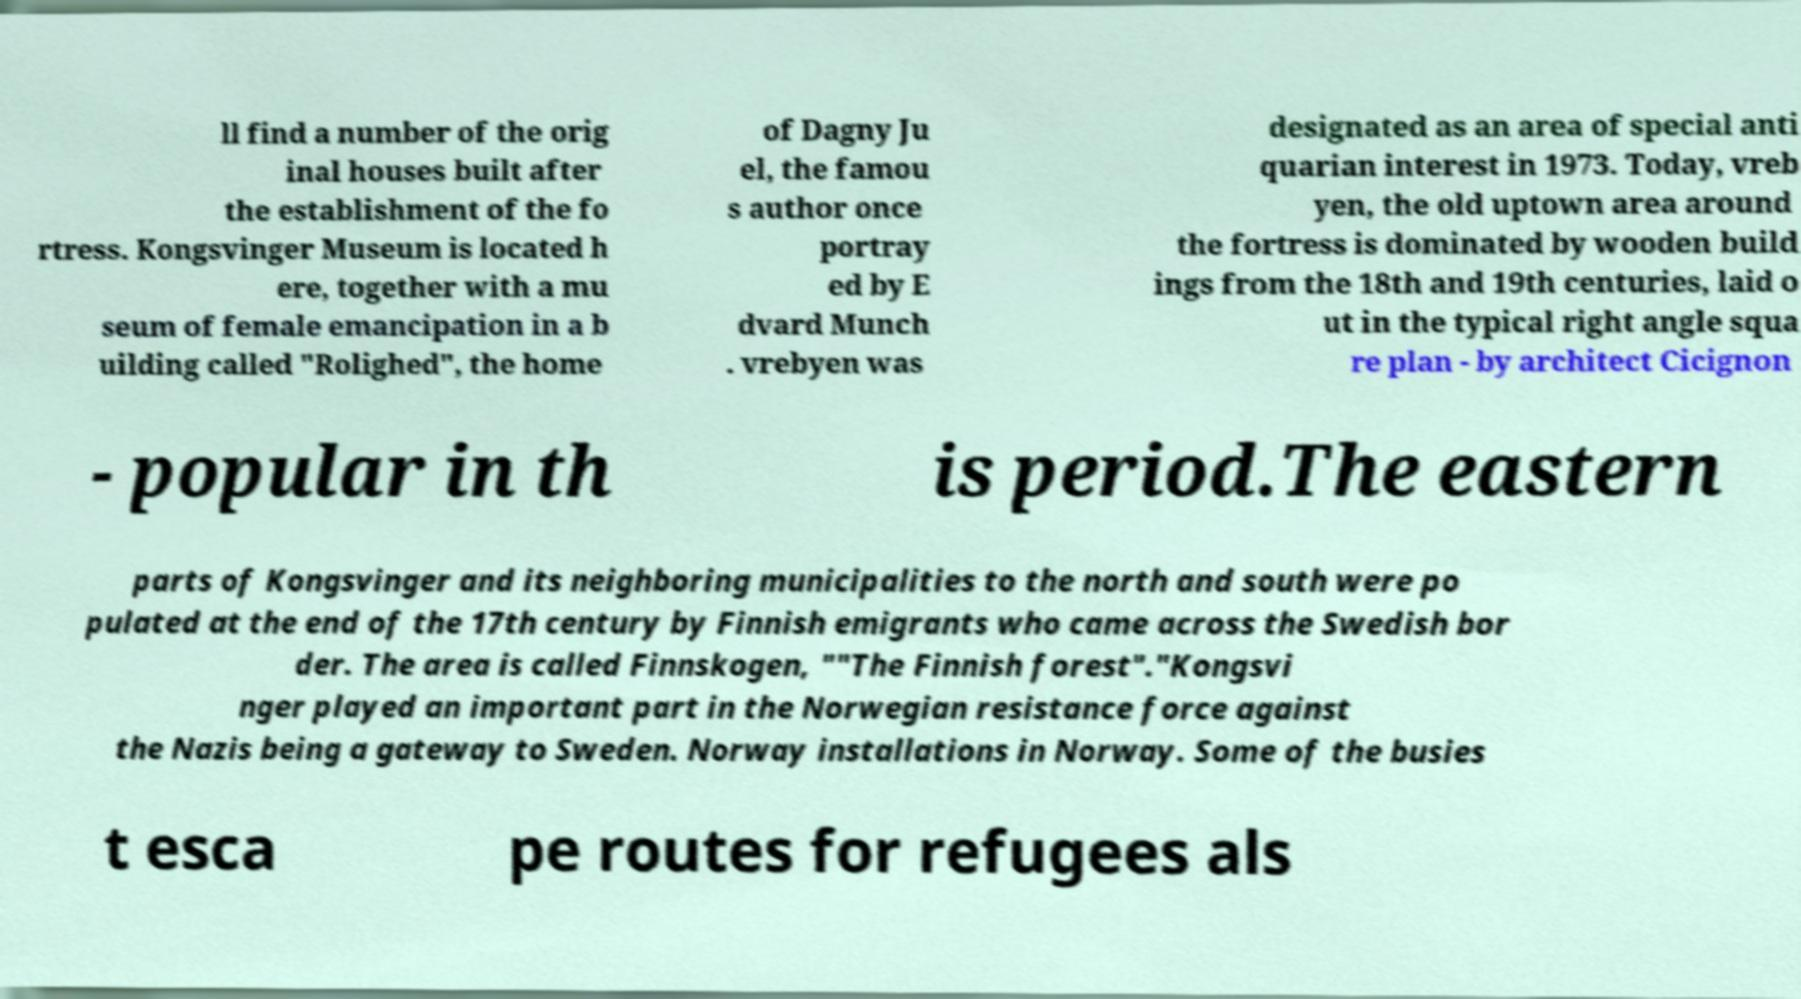I need the written content from this picture converted into text. Can you do that? ll find a number of the orig inal houses built after the establishment of the fo rtress. Kongsvinger Museum is located h ere, together with a mu seum of female emancipation in a b uilding called "Rolighed", the home of Dagny Ju el, the famou s author once portray ed by E dvard Munch . vrebyen was designated as an area of special anti quarian interest in 1973. Today, vreb yen, the old uptown area around the fortress is dominated by wooden build ings from the 18th and 19th centuries, laid o ut in the typical right angle squa re plan - by architect Cicignon - popular in th is period.The eastern parts of Kongsvinger and its neighboring municipalities to the north and south were po pulated at the end of the 17th century by Finnish emigrants who came across the Swedish bor der. The area is called Finnskogen, ""The Finnish forest"."Kongsvi nger played an important part in the Norwegian resistance force against the Nazis being a gateway to Sweden. Norway installations in Norway. Some of the busies t esca pe routes for refugees als 